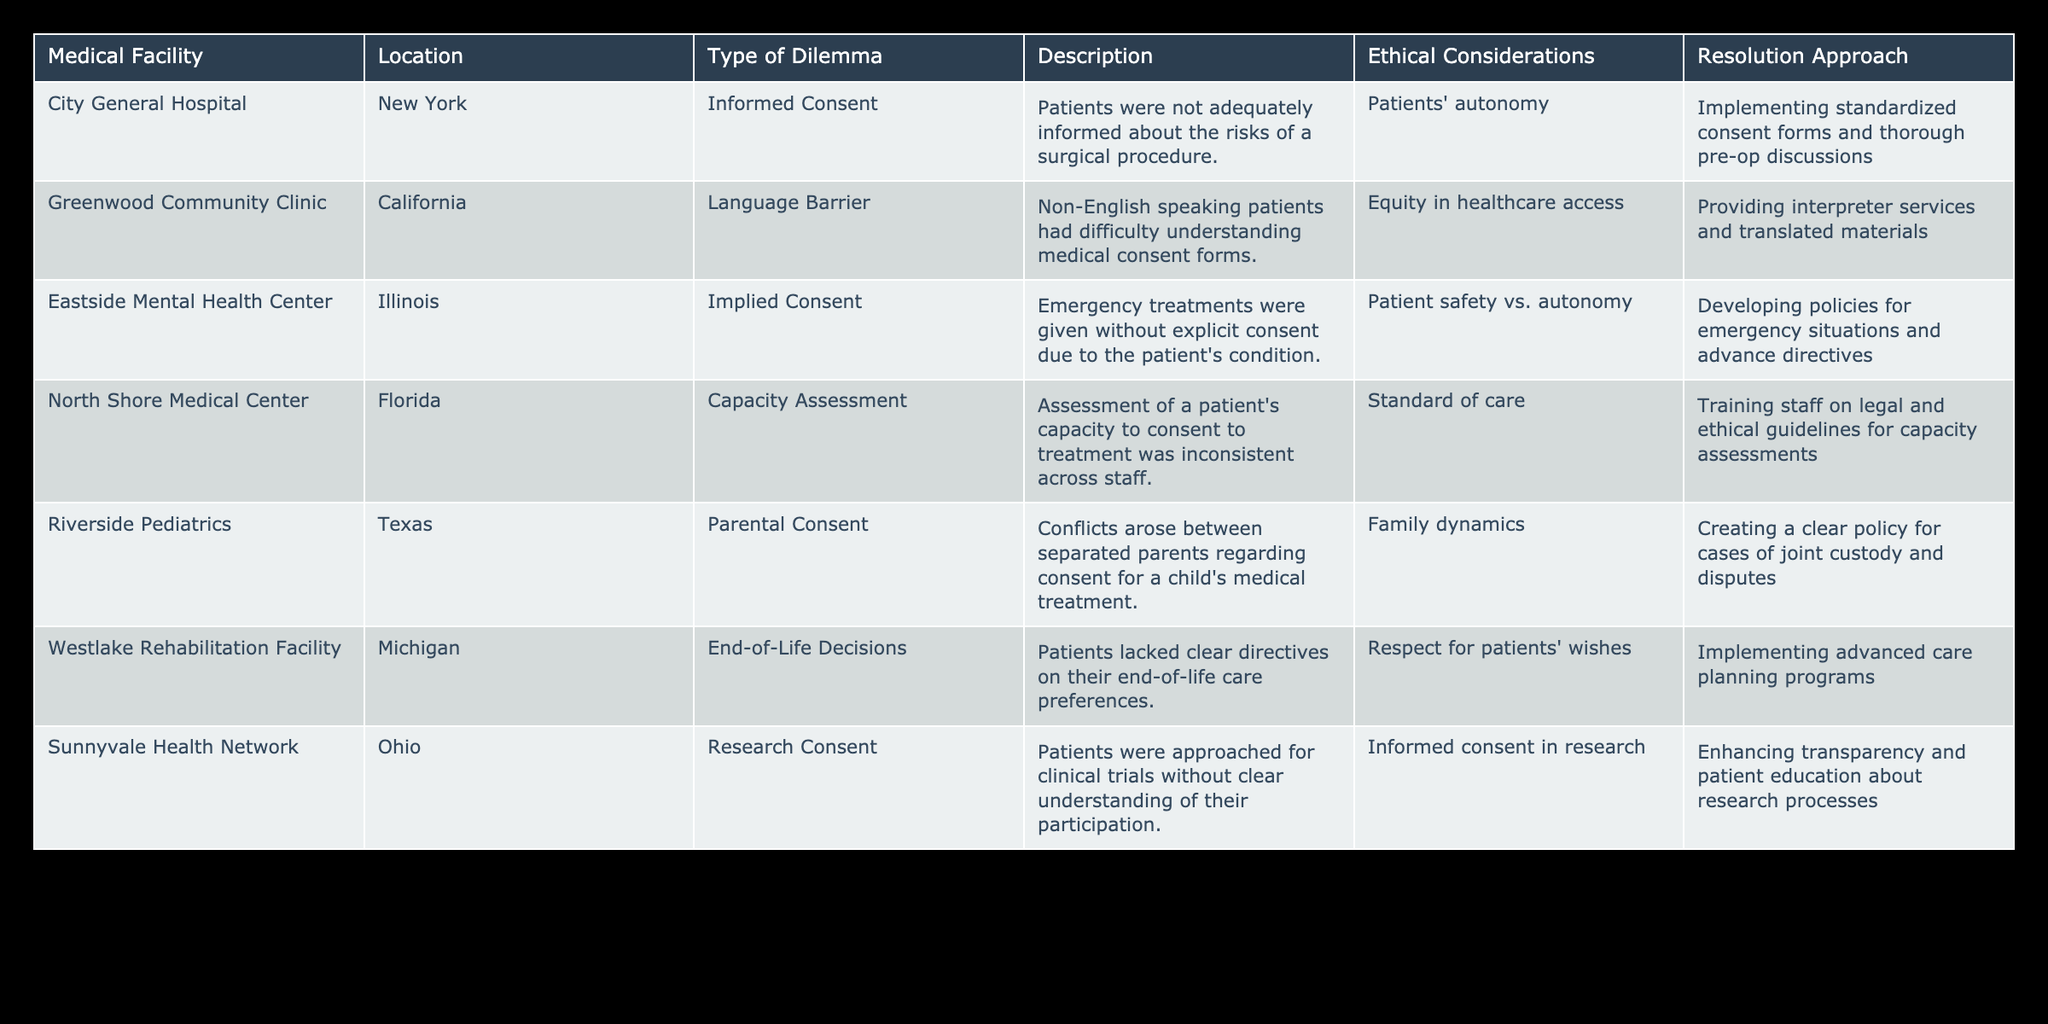What type of dilemma is reported by Eastside Mental Health Center? The table lists "Implied Consent" as the type of dilemma for Eastside Mental Health Center.
Answer: Implied Consent Which medical facility is located in Florida? The table shows that North Shore Medical Center is located in Florida.
Answer: North Shore Medical Center How many facilities have a dilemma related to consent in research? The table indicates that only Sunnyvale Health Network has a dilemma related to research consent.
Answer: 1 True or False: All facilities address patient safety in their resolution approaches. Looking through the table, only Eastside Mental Health Center clearly mentions a resolution approach related to patient safety; others focus on varying aspects like autonomy and family dynamics. Therefore, it is false.
Answer: False What is the primary ethical consideration for consent dilemmas at Greenwood Community Clinic? The primary ethical consideration for Greenwood Community Clinic is "Equity in healthcare access," as detailed in the table.
Answer: Equity in healthcare access Which facility has implemented advanced care planning programs? The table specifies that Westlake Rehabilitation Facility has implemented these programs to address end-of-life decisions.
Answer: Westlake Rehabilitation Facility Calculate the total number of facilities listed in the table. There are 7 rows in the data, each representing a unique facility, so the total number is 7.
Answer: 7 What are the main resolutions for addressing parental consent conflicts at Riverside Pediatrics? The main resolution approach for Riverside Pediatrics is to create a clear policy for cases of joint custody and disputes.
Answer: Creating a clear policy for cases of joint custody Which facility faced issues due to language barriers and what was the resolution approach? Greenwood Community Clinic faced language barrier issues and the resolution approach includes providing interpreter services and translated materials.
Answer: Providing interpreter services and translated materials 